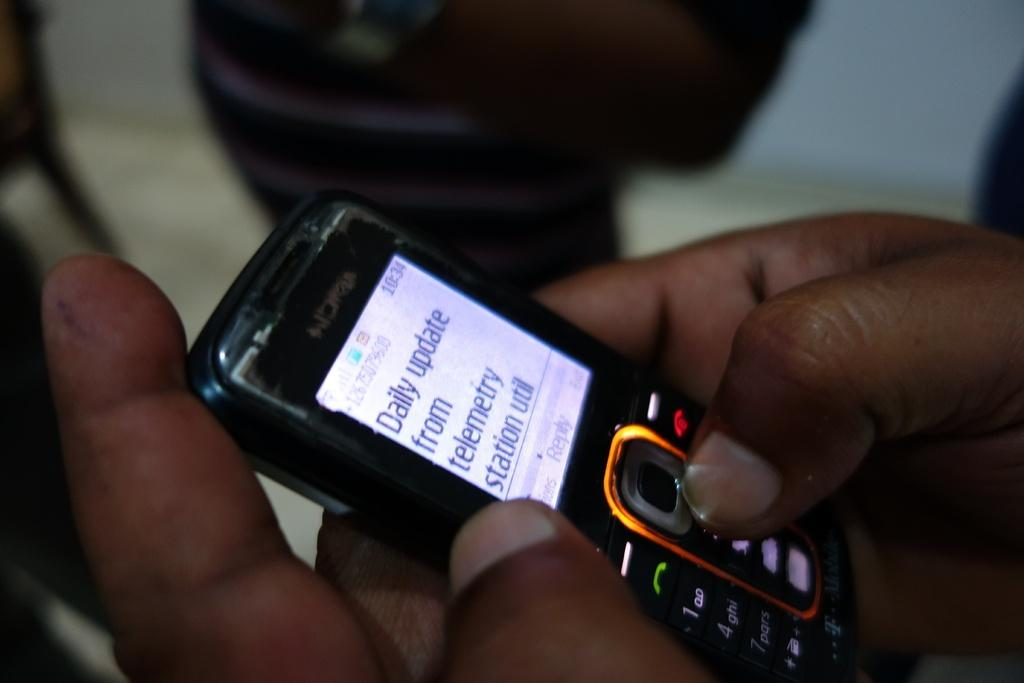Provide a one-sentence caption for the provided image. A cell phone with a daily update on it. 